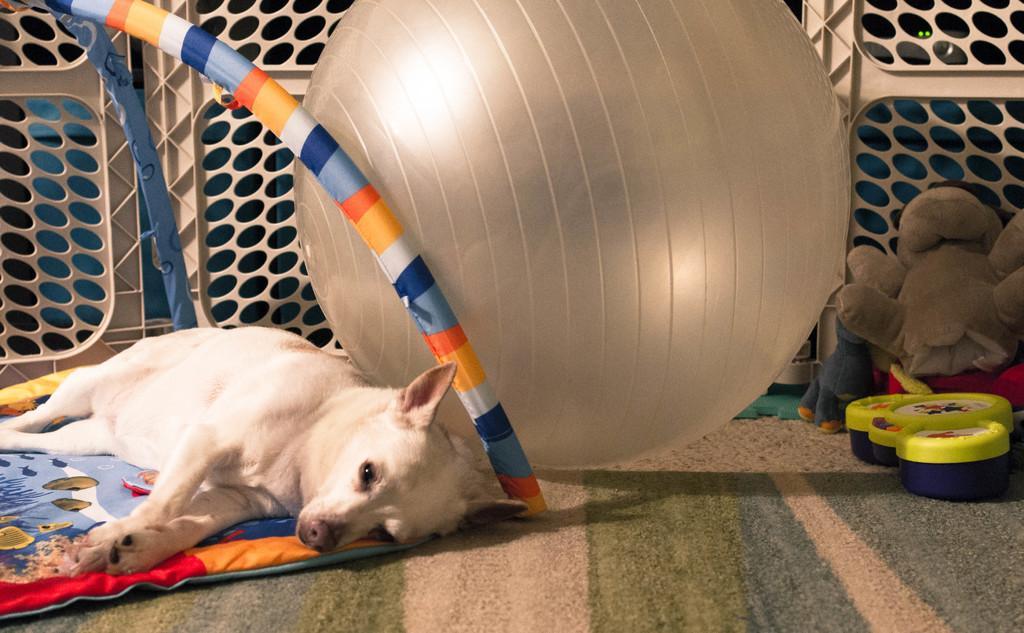Can you describe this image briefly? In this image we can see a dog lying on the floor, carpet, soft toys and a quilt. 